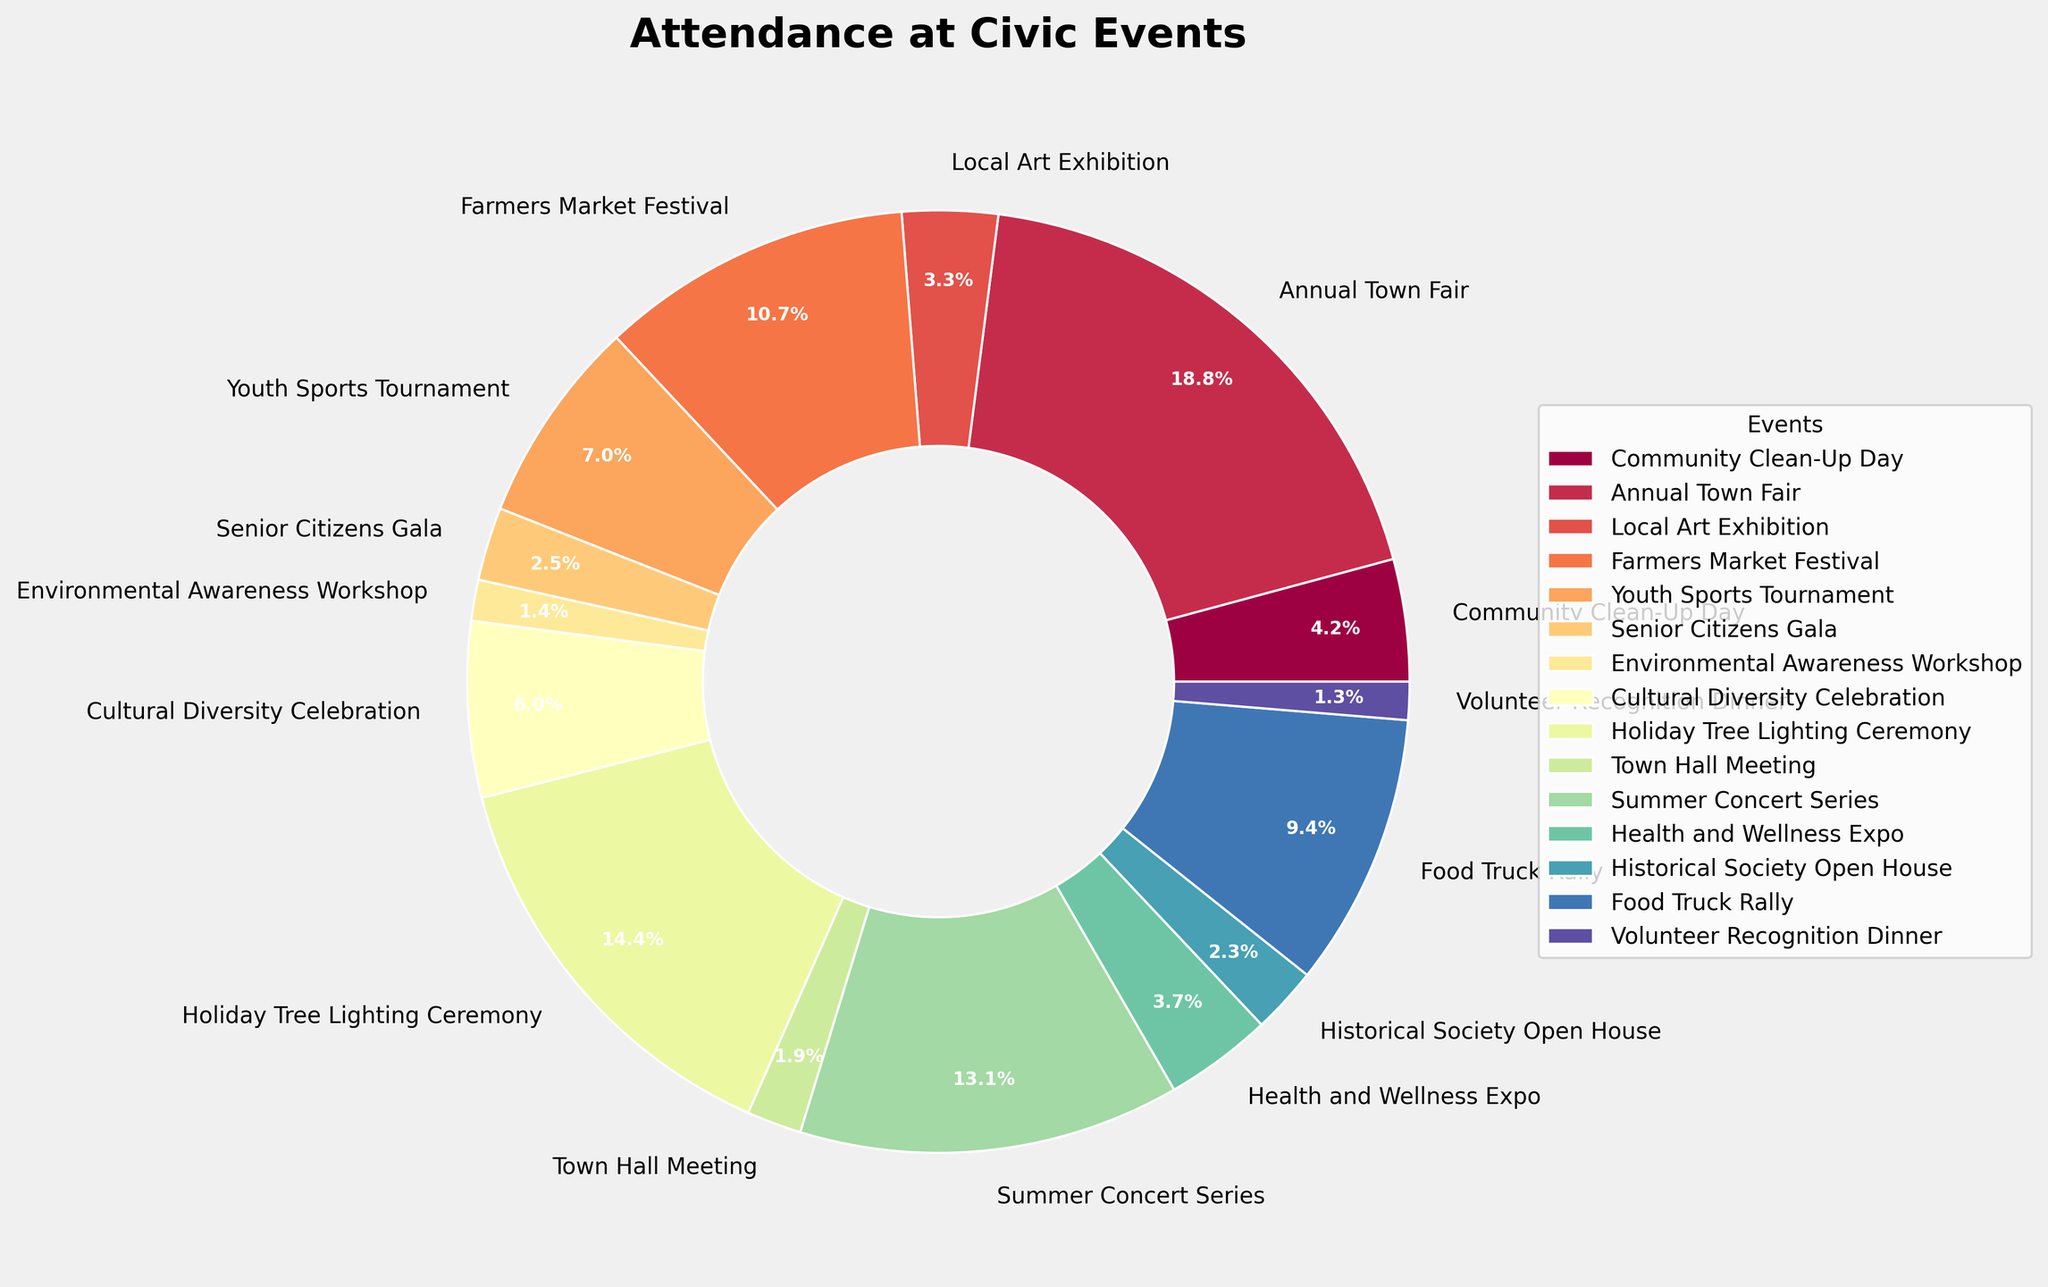What's the most attended civic event? To determine the most attended event, look at the segment of the pie chart with the largest percentage or area. According to the chart, the Annual Town Fair has the largest segment.
Answer: Annual Town Fair What's the least attended civic event? To find the least attended event, look at the smallest segment of the pie chart. According to the chart, the Volunteer Recognition Dinner has the smallest segment.
Answer: Volunteer Recognition Dinner How does the attendance of the Holiday Tree Lighting Ceremony compare to the Community Clean-Up Day? To compare these two, look at the size of their respective segments or percentages. The Holiday Tree Lighting Ceremony has a larger segment than the Community Clean-Up Day, indicating higher attendance.
Answer: Holiday Tree Lighting Ceremony has higher attendance What percentage of the total attendance does the Farmers Market Festival represent? The Farmers Market Festival segment corresponds to its percentage of total attendance. The pie chart labels this percentage, which is approximately 16.2% of total attendance.
Answer: 16.2% Which event had more attendees: Youth Sports Tournament or Food Truck Rally? To determine which event had more attendees, compare the sizes of their segments on the pie chart. The Food Truck Rally has a larger segment compared to the Youth Sports Tournament.
Answer: Food Truck Rally What's the combined attendance of Senior Citizens Gala and Health and Wellness Expo? Find the attendance numbers for both events from the chart, then add them together. The Senior Citizens Gala has 750, and the Health and Wellness Expo has 1100 attendees. Combined, they have 750 + 1100 = 1850 attendees.
Answer: 1850 What is the difference in attendance between the Local Art Exhibition and the Town Hall Meeting? Check the attendance numbers on the chart for both events. The Local Art Exhibition has 980 attendees, and the Town Hall Meeting has 560 attendees. The difference is 980 - 560 = 420.
Answer: 420 What is the average attendance of all the civic events? Sum the attendance numbers for all events and divide by the number of events. The total attendance is 30480, and there are 15 events. The average attendance is 30480 / 15 = 2032.
Answer: 2032 Which event has a larger segment in the pie chart: Cultural Diversity Celebration or Summer Concert Series? Compare the size of the segments for both events in the pie chart. The Summer Concert Series has a larger segment than the Cultural Diversity Celebration.
Answer: Summer Concert Series 